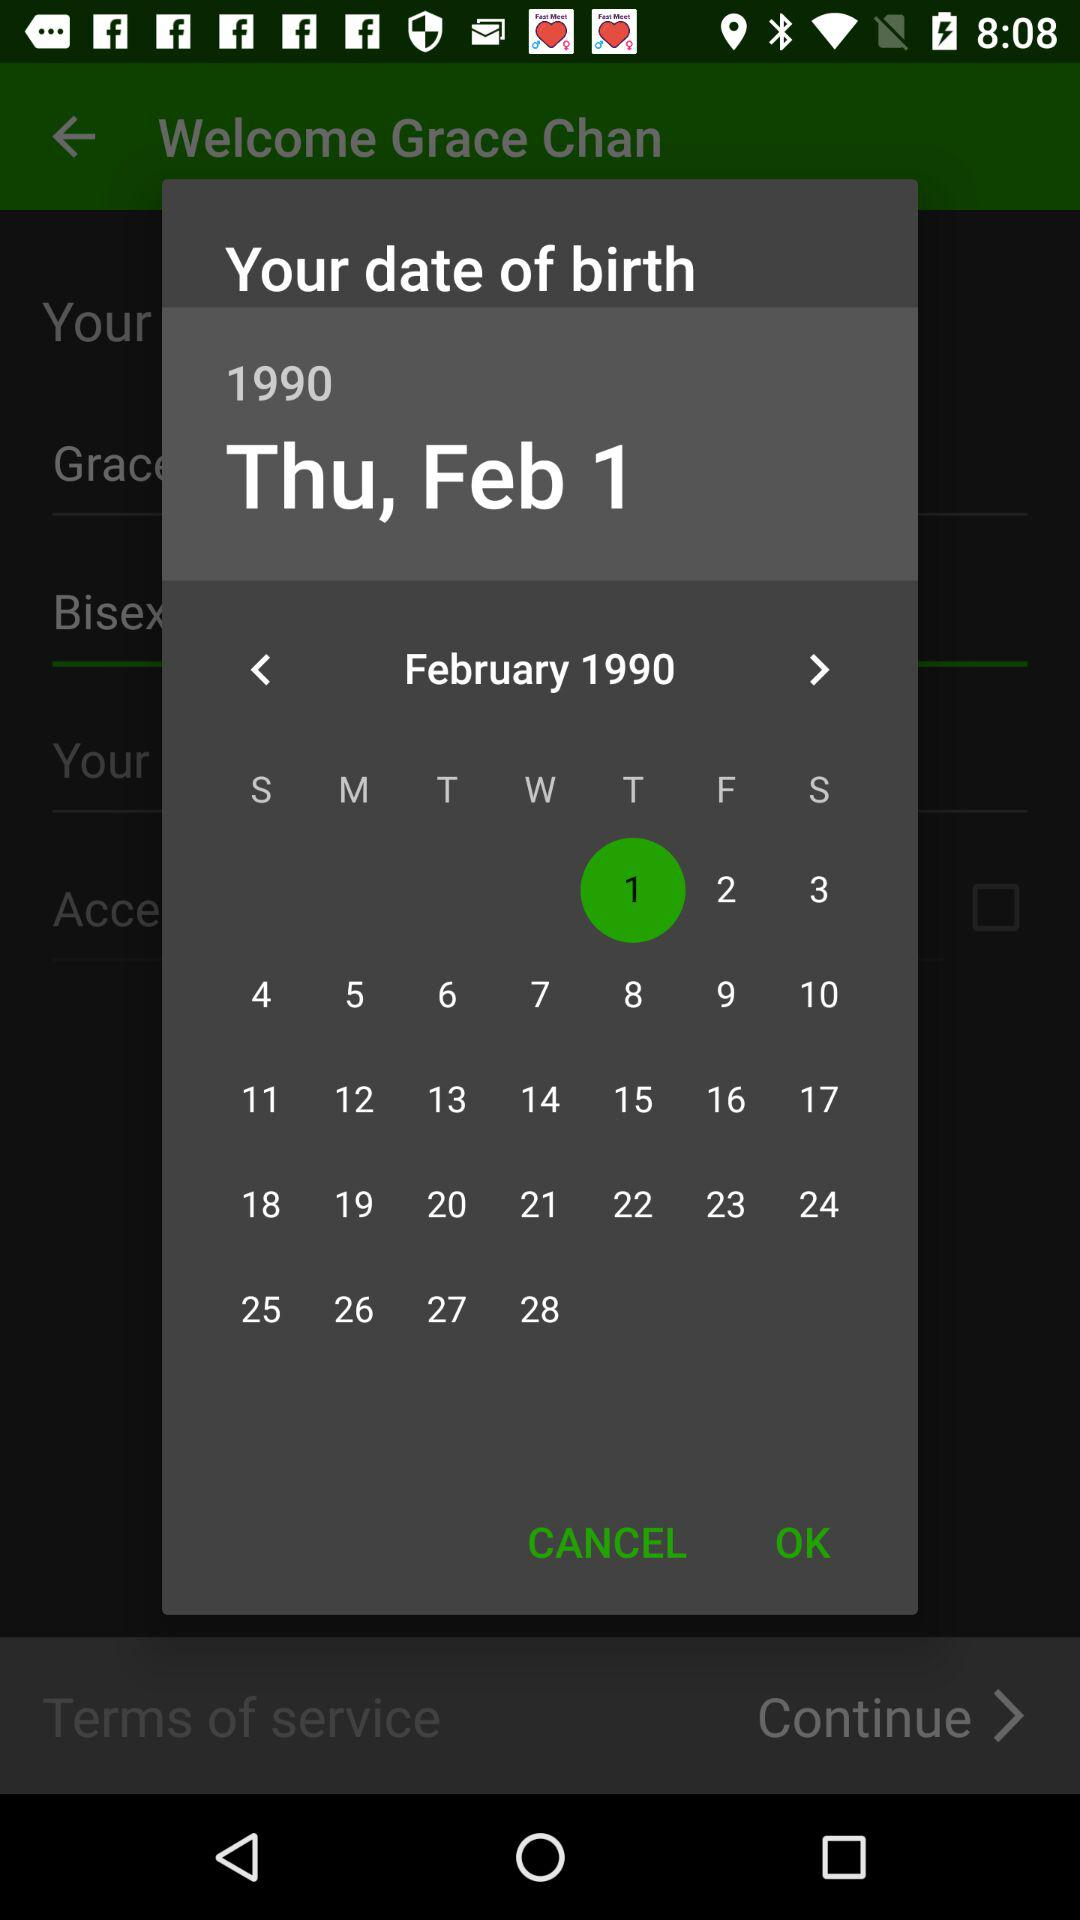What is the day of the selected date? The day is Thursday. 